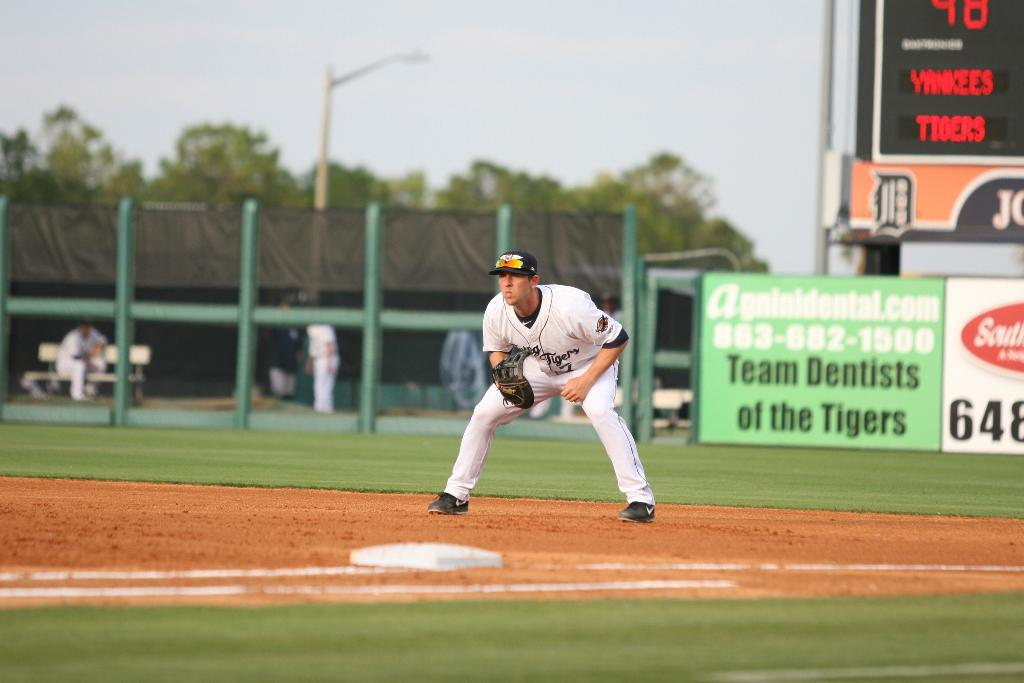Provide a one-sentence caption for the provided image. A sign at the baseball field reads 'Team Dentists of the Tigers'. 